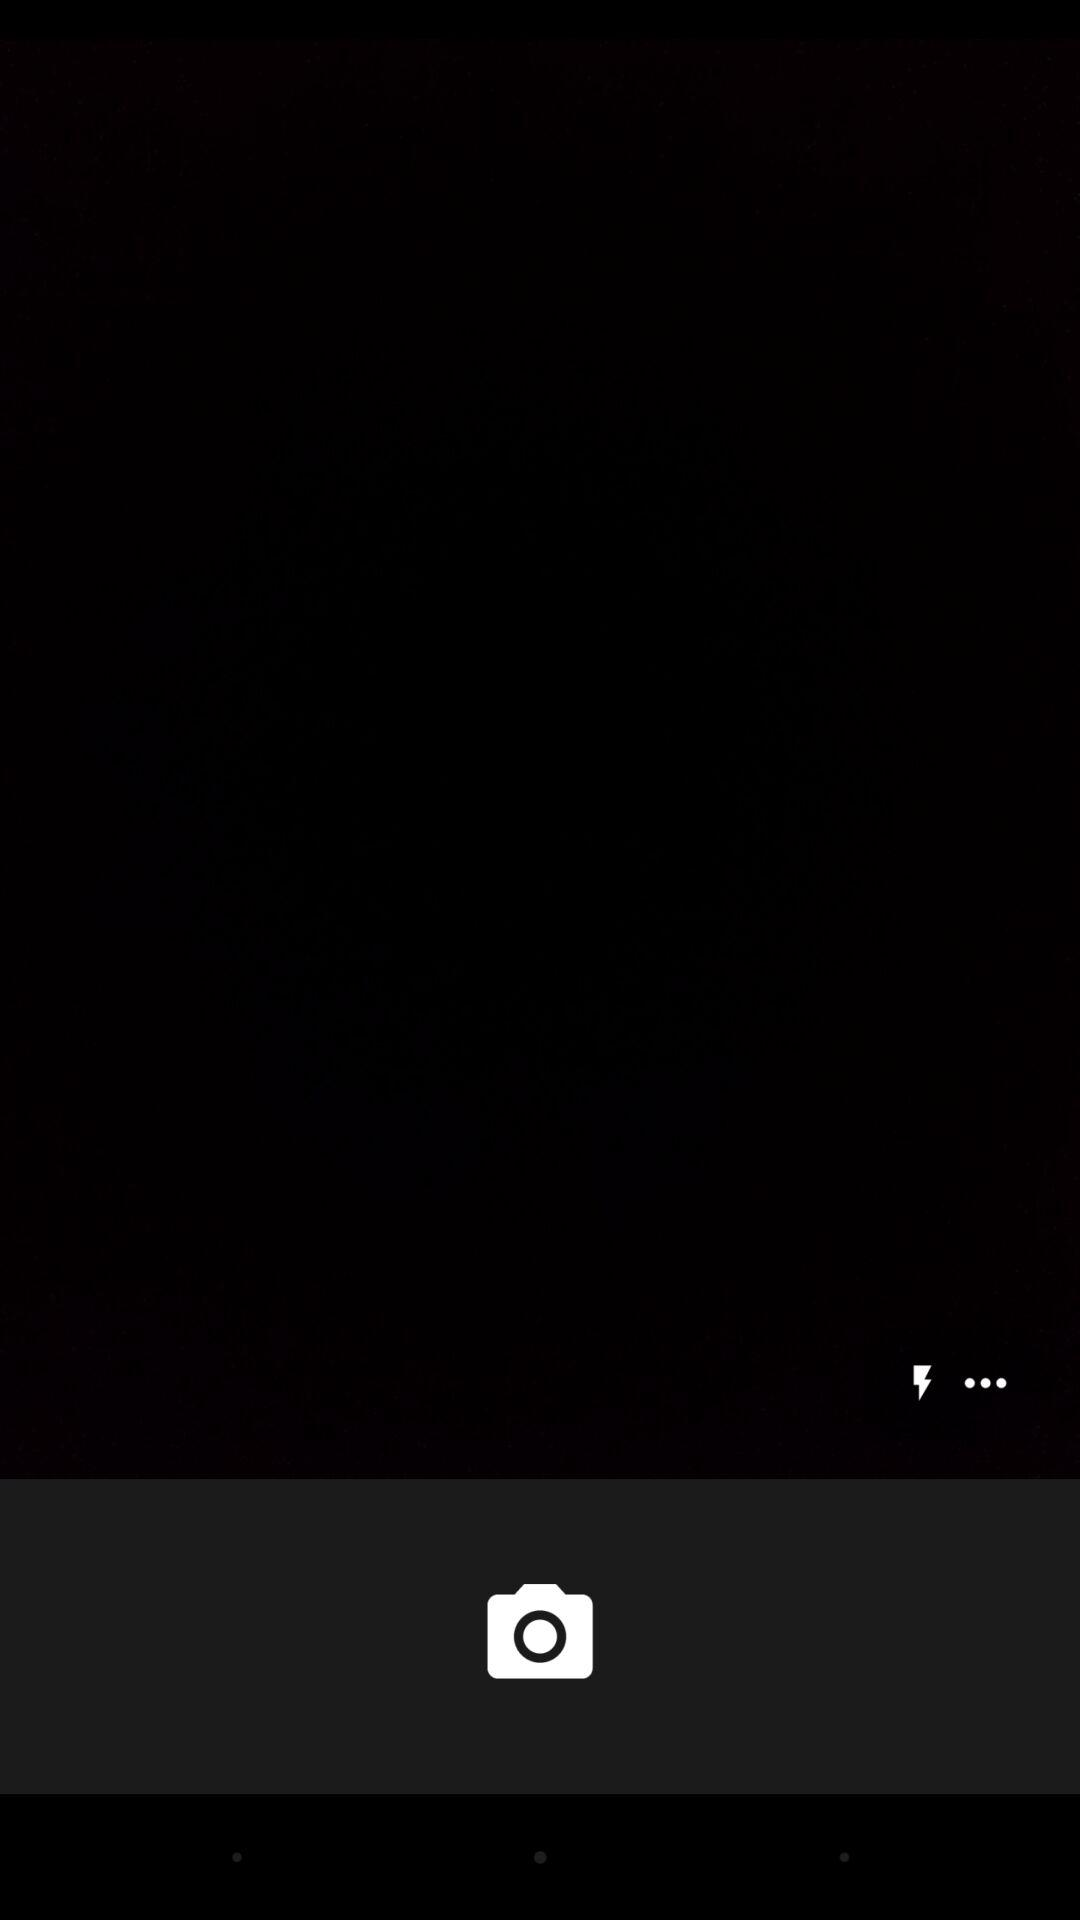How many more dots are there than lightning bolts?
Answer the question using a single word or phrase. 2 